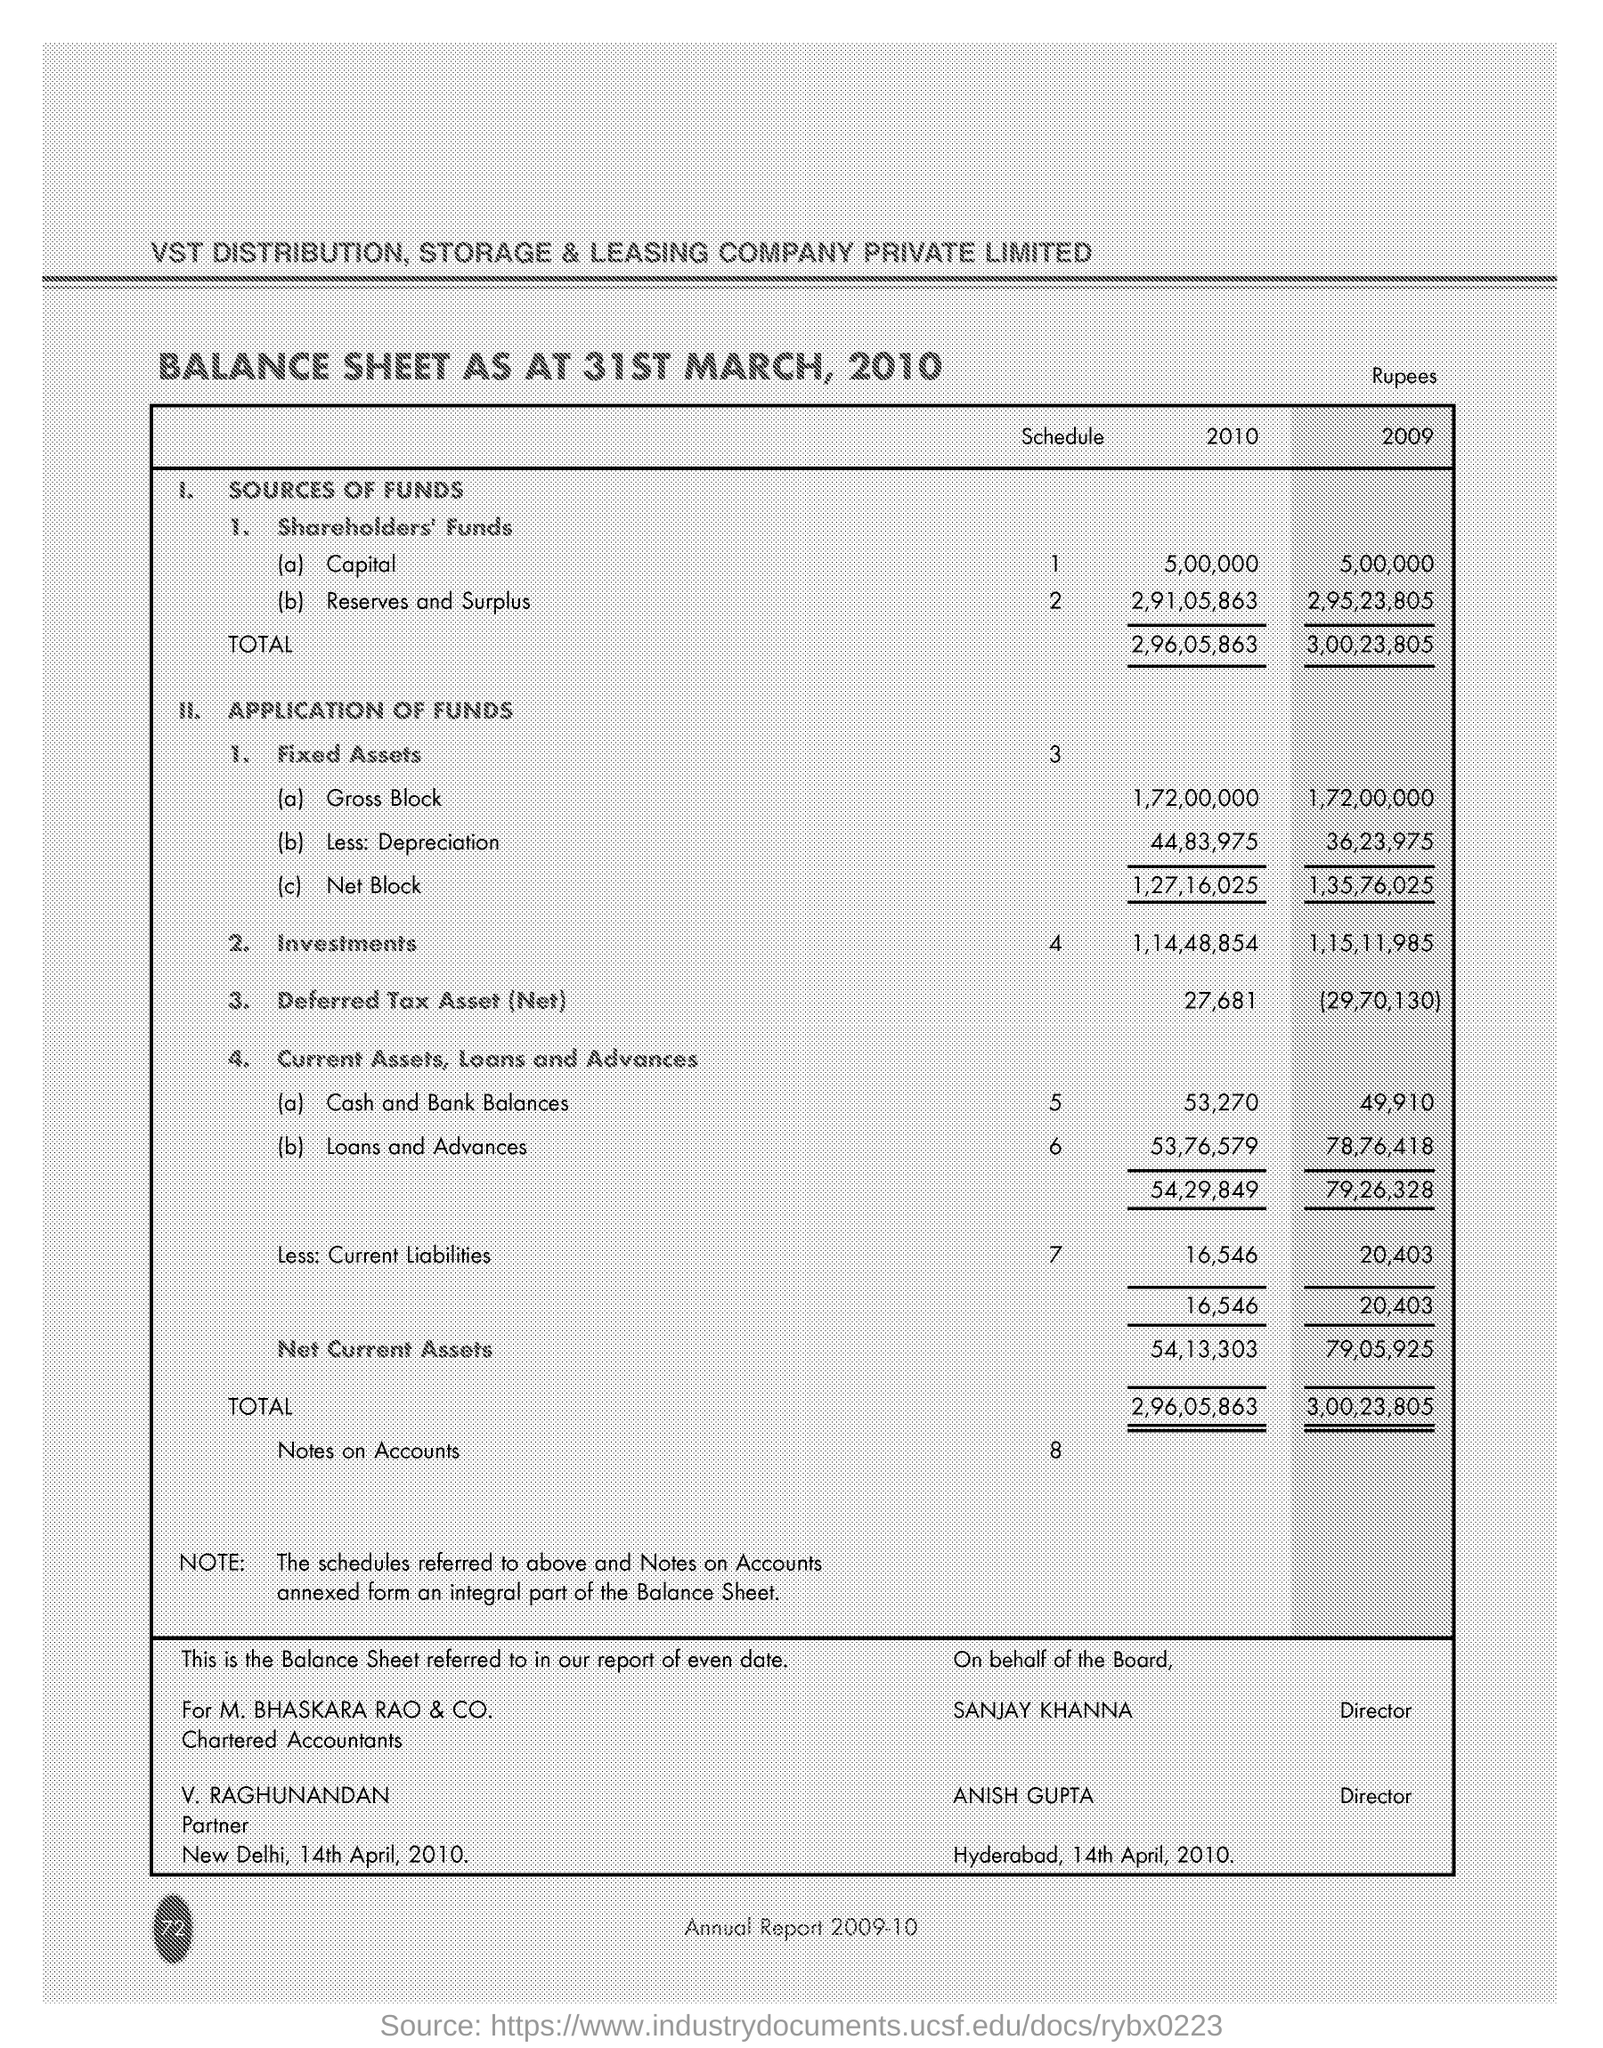When was this BALANCE SHEET prepared?
Keep it short and to the point. 31ST MARCH , 2010. Who was the  Chartered Accountants?
Keep it short and to the point. M. Bhaskara Rao & Co. 